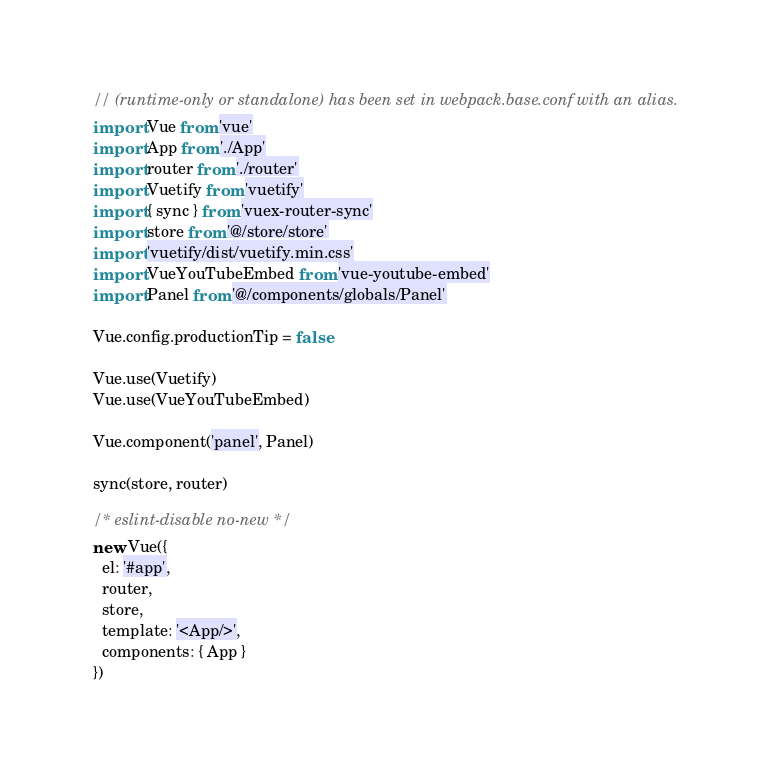Convert code to text. <code><loc_0><loc_0><loc_500><loc_500><_JavaScript_>// (runtime-only or standalone) has been set in webpack.base.conf with an alias.
import Vue from 'vue'
import App from './App'
import router from './router'
import Vuetify from 'vuetify'
import { sync } from 'vuex-router-sync'
import store from '@/store/store'
import 'vuetify/dist/vuetify.min.css'
import VueYouTubeEmbed from 'vue-youtube-embed'
import Panel from '@/components/globals/Panel'

Vue.config.productionTip = false

Vue.use(Vuetify)
Vue.use(VueYouTubeEmbed)

Vue.component('panel', Panel)

sync(store, router)

/* eslint-disable no-new */
new Vue({
  el: '#app',
  router,
  store,
  template: '<App/>',
  components: { App }
})
</code> 